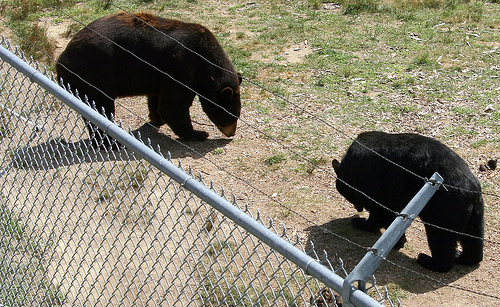How many bears are there? There are two bears visible in the image. They appear to be moving around a grassy area, separated by a metal fence, which could indicate that they are in a sanctuary or a zoo. 